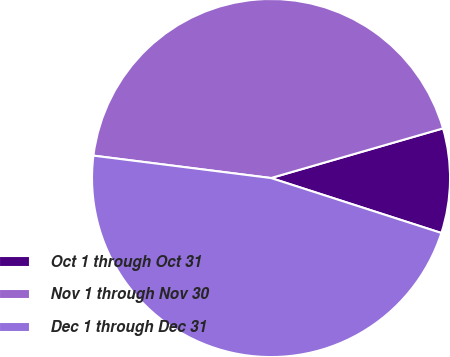<chart> <loc_0><loc_0><loc_500><loc_500><pie_chart><fcel>Oct 1 through Oct 31<fcel>Nov 1 through Nov 30<fcel>Dec 1 through Dec 31<nl><fcel>9.44%<fcel>43.53%<fcel>47.03%<nl></chart> 